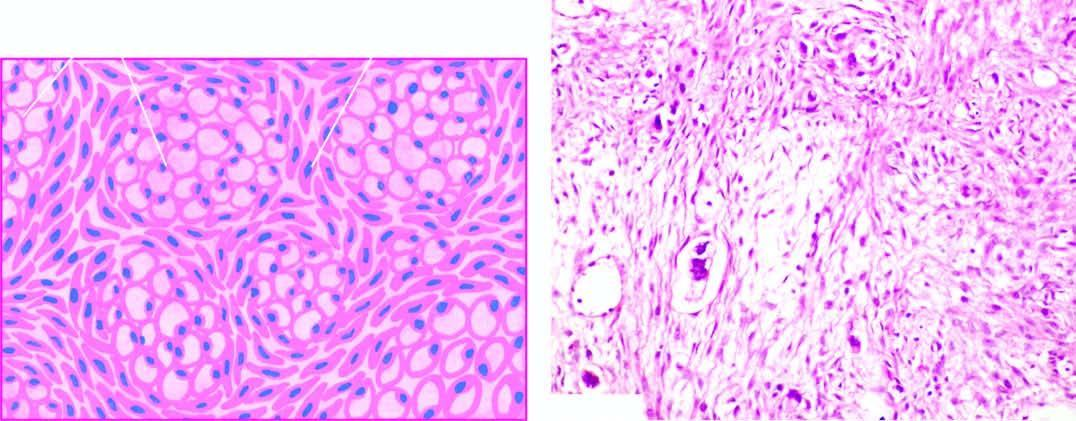what do histologic features include?
Answer the question using a single word or phrase. Mucin-filled signet-ring cells and richly cellular proliferation of the ovarian stroma 